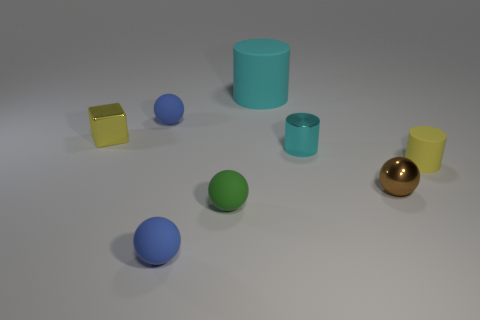Which object appears to be the largest in this image? The largest object in the image is the cyan cylinder that stands vertically on the surface. 